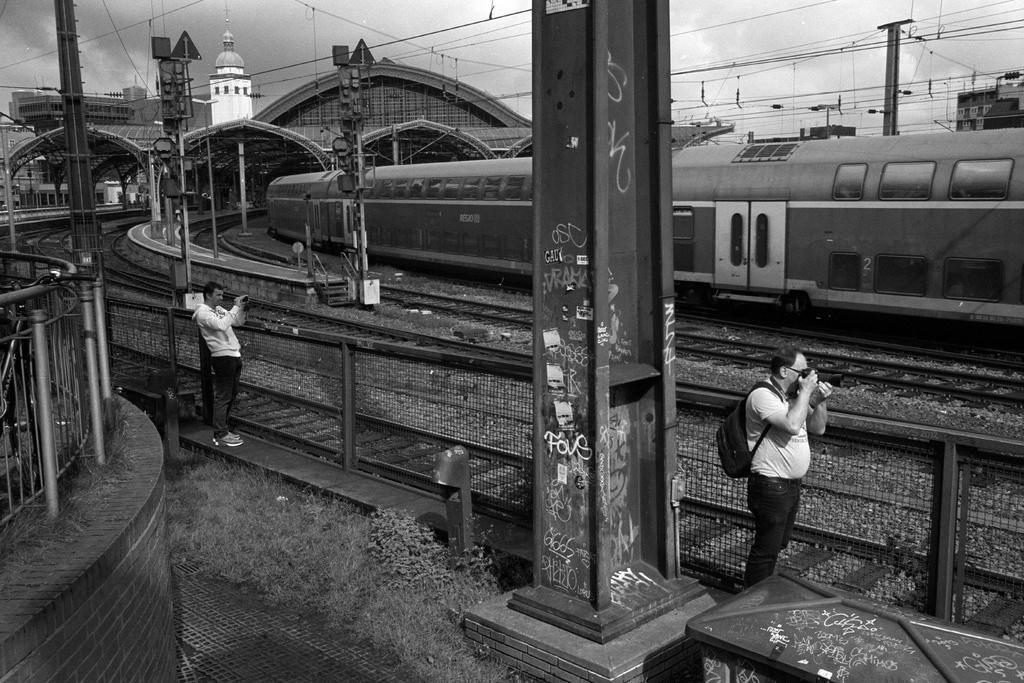Could you give a brief overview of what you see in this image? This is a black and white image. In the center of the image we can see a pole. On the right side of the image we can see person, fencing and train on a railway track. On the left side of the image we can see building, station, fencing, person, platform and railway tracks. In the background we can see wires, poles, building, sky and clouds. 